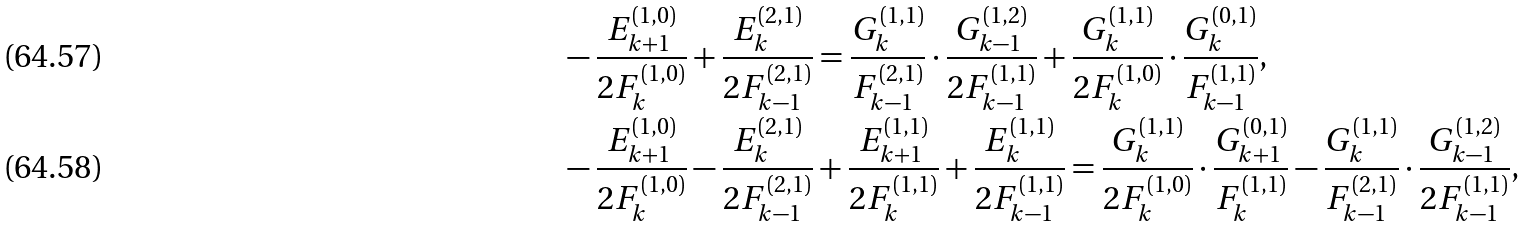Convert formula to latex. <formula><loc_0><loc_0><loc_500><loc_500>& - \frac { E _ { k + 1 } ^ { ( 1 , 0 ) } } { 2 F _ { k } ^ { ( 1 , 0 ) } } + \frac { E _ { k } ^ { ( 2 , 1 ) } } { 2 F _ { k - 1 } ^ { ( 2 , 1 ) } } = \frac { G _ { k } ^ { ( 1 , 1 ) } } { F _ { k - 1 } ^ { ( 2 , 1 ) } } \cdot \frac { G _ { k - 1 } ^ { ( 1 , 2 ) } } { 2 F _ { k - 1 } ^ { ( 1 , 1 ) } } + \frac { G _ { k } ^ { ( 1 , 1 ) } } { 2 F _ { k } ^ { ( 1 , 0 ) } } \cdot \frac { G _ { k } ^ { ( 0 , 1 ) } } { F _ { k - 1 } ^ { ( 1 , 1 ) } } , \\ & - \frac { E _ { k + 1 } ^ { ( 1 , 0 ) } } { 2 F _ { k } ^ { ( 1 , 0 ) } } - \frac { E _ { k } ^ { ( 2 , 1 ) } } { 2 F _ { k - 1 } ^ { ( 2 , 1 ) } } + \frac { E _ { k + 1 } ^ { ( 1 , 1 ) } } { 2 F _ { k } ^ { ( 1 , 1 ) } } + \frac { E _ { k } ^ { ( 1 , 1 ) } } { 2 F _ { k - 1 } ^ { ( 1 , 1 ) } } = \frac { G _ { k } ^ { ( 1 , 1 ) } } { 2 F _ { k } ^ { ( 1 , 0 ) } } \cdot \frac { G _ { k + 1 } ^ { ( 0 , 1 ) } } { F _ { k } ^ { ( 1 , 1 ) } } - \frac { G _ { k } ^ { ( 1 , 1 ) } } { F _ { k - 1 } ^ { ( 2 , 1 ) } } \cdot \frac { G _ { k - 1 } ^ { ( 1 , 2 ) } } { 2 F _ { k - 1 } ^ { ( 1 , 1 ) } } ,</formula> 